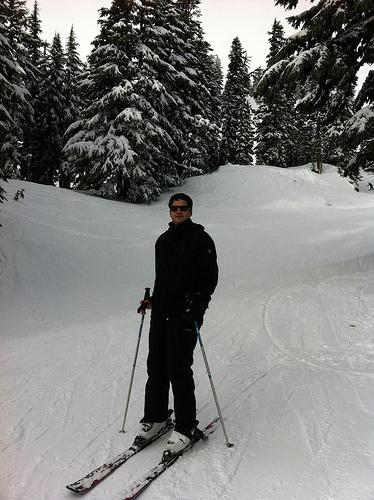Question: how is the man dressed?
Choices:
A. In a suit.
B. In clothes for skiing.
C. In a soccer uniform.
D. In a baseball uniform.
Answer with the letter. Answer: B Question: who is wearing sunglasses?
Choices:
A. The child.
B. The woman.
C. The baby.
D. The man.
Answer with the letter. Answer: D Question: what is the man standing on?
Choices:
A. Skis.
B. Skateboard.
C. Sidewalk.
D. Grass.
Answer with the letter. Answer: A Question: what is the man holding in his hands?
Choices:
A. Soda Can.
B. Bag.
C. Cell Phone.
D. Ski poles.
Answer with the letter. Answer: D Question: where was this taken?
Choices:
A. On a beach.
B. At a park.
C. Outside.
D. On a ski slope.
Answer with the letter. Answer: D 